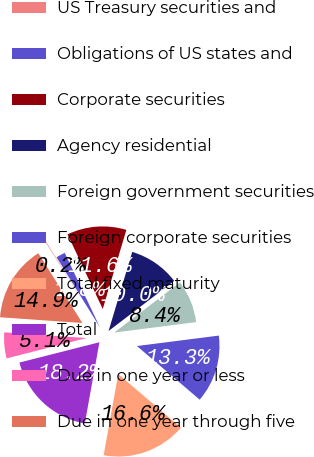Convert chart. <chart><loc_0><loc_0><loc_500><loc_500><pie_chart><fcel>US Treasury securities and<fcel>Obligations of US states and<fcel>Corporate securities<fcel>Agency residential<fcel>Foreign government securities<fcel>Foreign corporate securities<fcel>Total fixed maturity<fcel>Total<fcel>Due in one year or less<fcel>Due in one year through five<nl><fcel>0.15%<fcel>1.79%<fcel>11.64%<fcel>10.0%<fcel>8.36%<fcel>13.28%<fcel>16.57%<fcel>18.21%<fcel>5.07%<fcel>14.93%<nl></chart> 